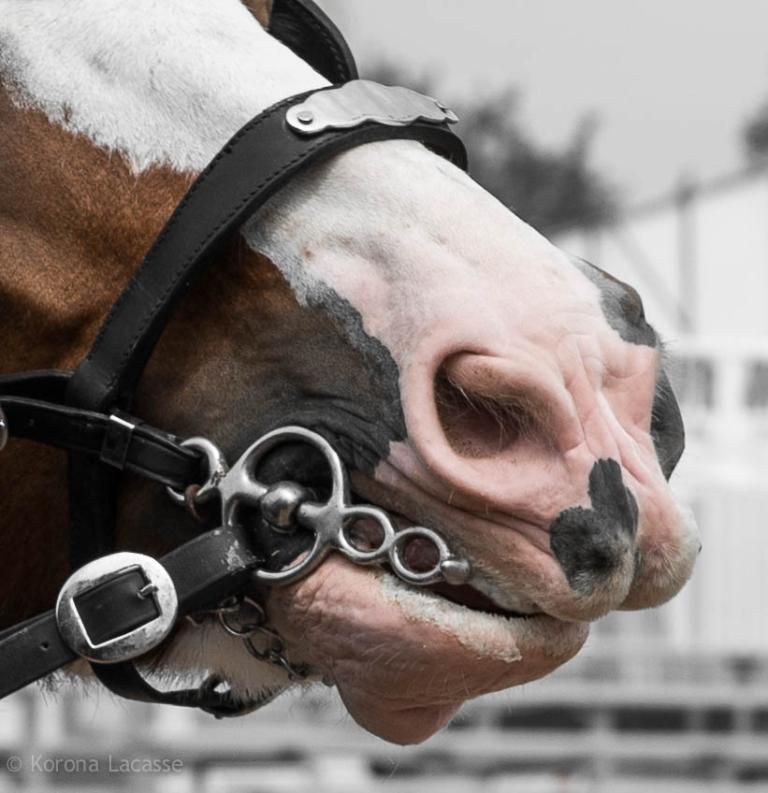What type of object is featured in the image? There is an animal face part in the image. What other items can be seen in the image? Belts are present in the image. How would you describe the background of the image? The background of the image is blurry. Can you describe the specific area of the image that is blurry? The bottom left side of the image is blurry. How many rings are visible on the animal face part in the image? There are no rings present on the animal face part in the image. What type of vegetable is being used as a prop in the image? There is no vegetable, such as cabbage, present in the image. 